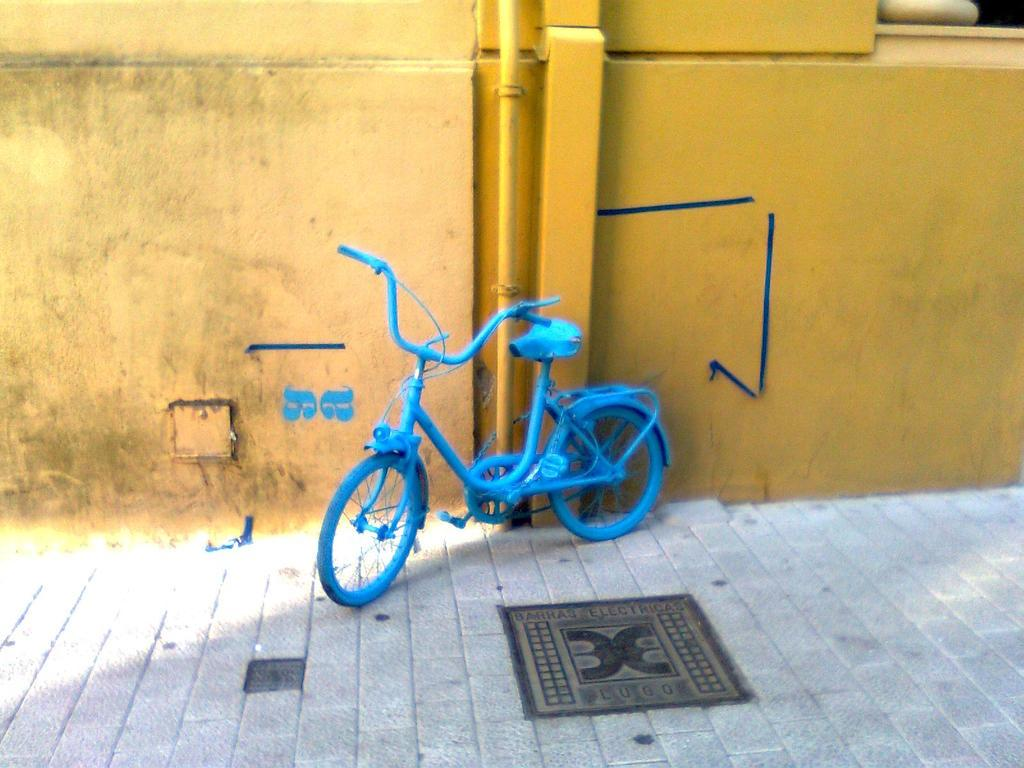What type of vehicle is in the image? There is a blue bicycle in the image. What color is the wall behind the bicycle? The wall behind the bicycle is yellow. Where is the bicycle located? The bicycle is on a footpath. How many hands are visible holding the bicycle in the image? There are no hands visible holding the bicycle in the image. Is there a maid in the image? There is no mention of a maid in the image. 